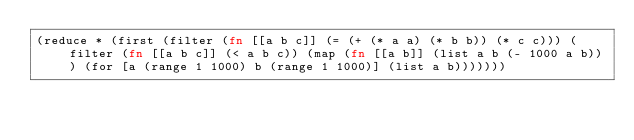Convert code to text. <code><loc_0><loc_0><loc_500><loc_500><_Clojure_>(reduce * (first (filter (fn [[a b c]] (= (+ (* a a) (* b b)) (* c c))) (filter (fn [[a b c]] (< a b c)) (map (fn [[a b]] (list a b (- 1000 a b))) (for [a (range 1 1000) b (range 1 1000)] (list a b)))))))
</code> 